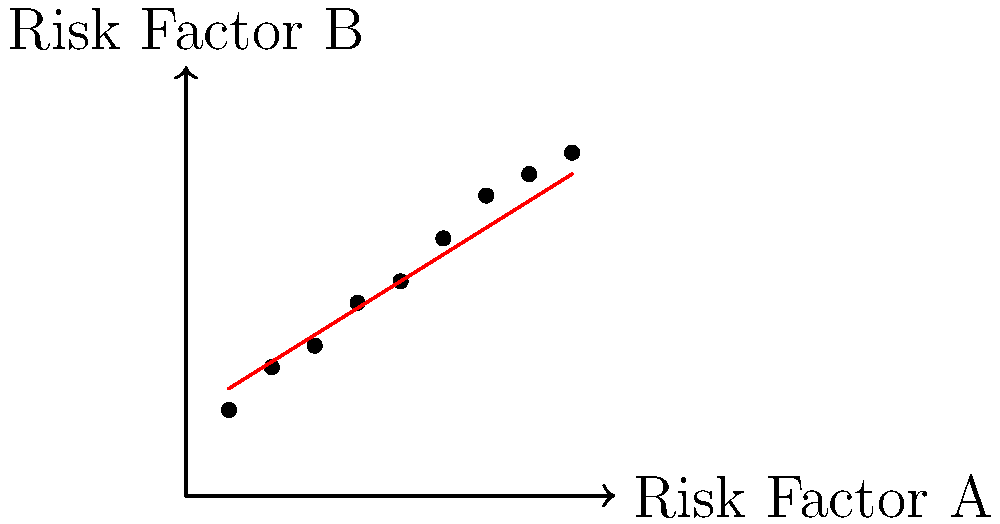Based on the scatter plot showing the relationship between Risk Factor A and Risk Factor B in a multivariate model, what can be inferred about the correlation between these two risk factors? Additionally, calculate the approximate correlation coefficient (r) using the formula $r = \frac{\text{cov}(X,Y)}{\sigma_X \sigma_Y}$, where $\text{cov}(X,Y)$ is the covariance of X and Y, and $\sigma_X$ and $\sigma_Y$ are the standard deviations of X and Y respectively. To interpret the scatter plot and calculate the correlation coefficient, we'll follow these steps:

1. Visual interpretation:
   The scatter plot shows a clear positive trend, with points generally moving from the bottom-left to the top-right. This indicates a positive correlation between Risk Factor A and Risk Factor B.

2. Strength of correlation:
   The points are fairly close to the trend line, suggesting a strong positive correlation.

3. Calculating the correlation coefficient:
   To calculate r, we need to estimate the covariance and standard deviations.

   a) First, let's estimate the means:
      $\bar{X} \approx 5$, $\bar{Y} \approx 5$

   b) Calculate deviations from the mean:
      X deviations: -4, -3, -2, -1, 0, 1, 2, 3, 4
      Y deviations: -3, -2, -1.5, -0.5, 0, 1, 2, 2.5, 3

   c) Multiply corresponding deviations:
      12, 6, 3, 0.5, 0, 1, 4, 7.5, 12

   d) Sum the products and divide by n-1 to get covariance:
      $\text{cov}(X,Y) = \frac{46}{8} = 5.75$

   e) Calculate standard deviations:
      $\sigma_X = \sqrt{\frac{\sum(X-\bar{X})^2}{n-1}} \approx 2.74$
      $\sigma_Y = \sqrt{\frac{\sum(Y-\bar{Y})^2}{n-1}} \approx 2.06$

   f) Calculate r:
      $r = \frac{5.75}{2.74 \times 2.06} \approx 0.94$

4. Interpretation of r:
   The correlation coefficient of 0.94 indicates a very strong positive correlation between Risk Factor A and Risk Factor B.

In the context of risk management, this strong positive correlation suggests that as Risk Factor A increases, Risk Factor B tends to increase as well. This information is crucial for actuarial analysis, as it implies that these risk factors are not independent and may compound each other in risk assessments.
Answer: Strong positive correlation; r ≈ 0.94 